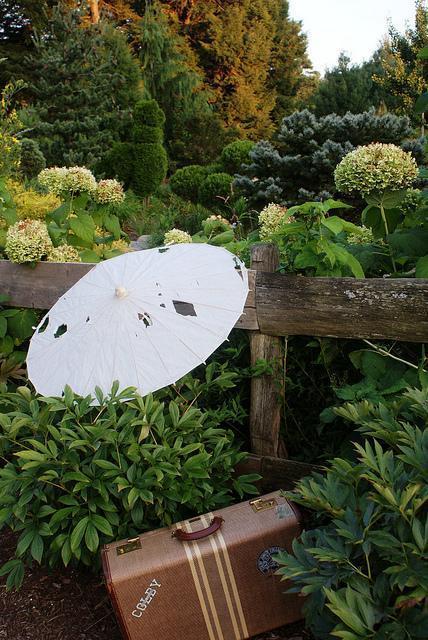How many people are there?
Give a very brief answer. 0. 